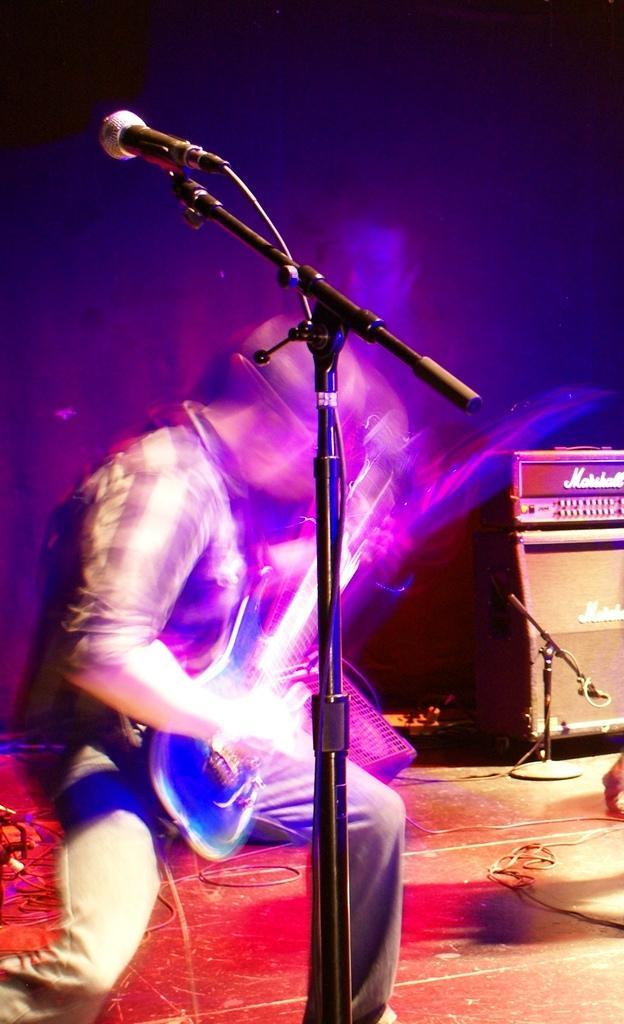In one or two sentences, can you explain what this image depicts? In this image I can see a person and I can see this person is holding a guitar. I can also see a mic, a speaker and I can see something is written over here. I can also see this image is little bit blurry and I can see black color in background. 